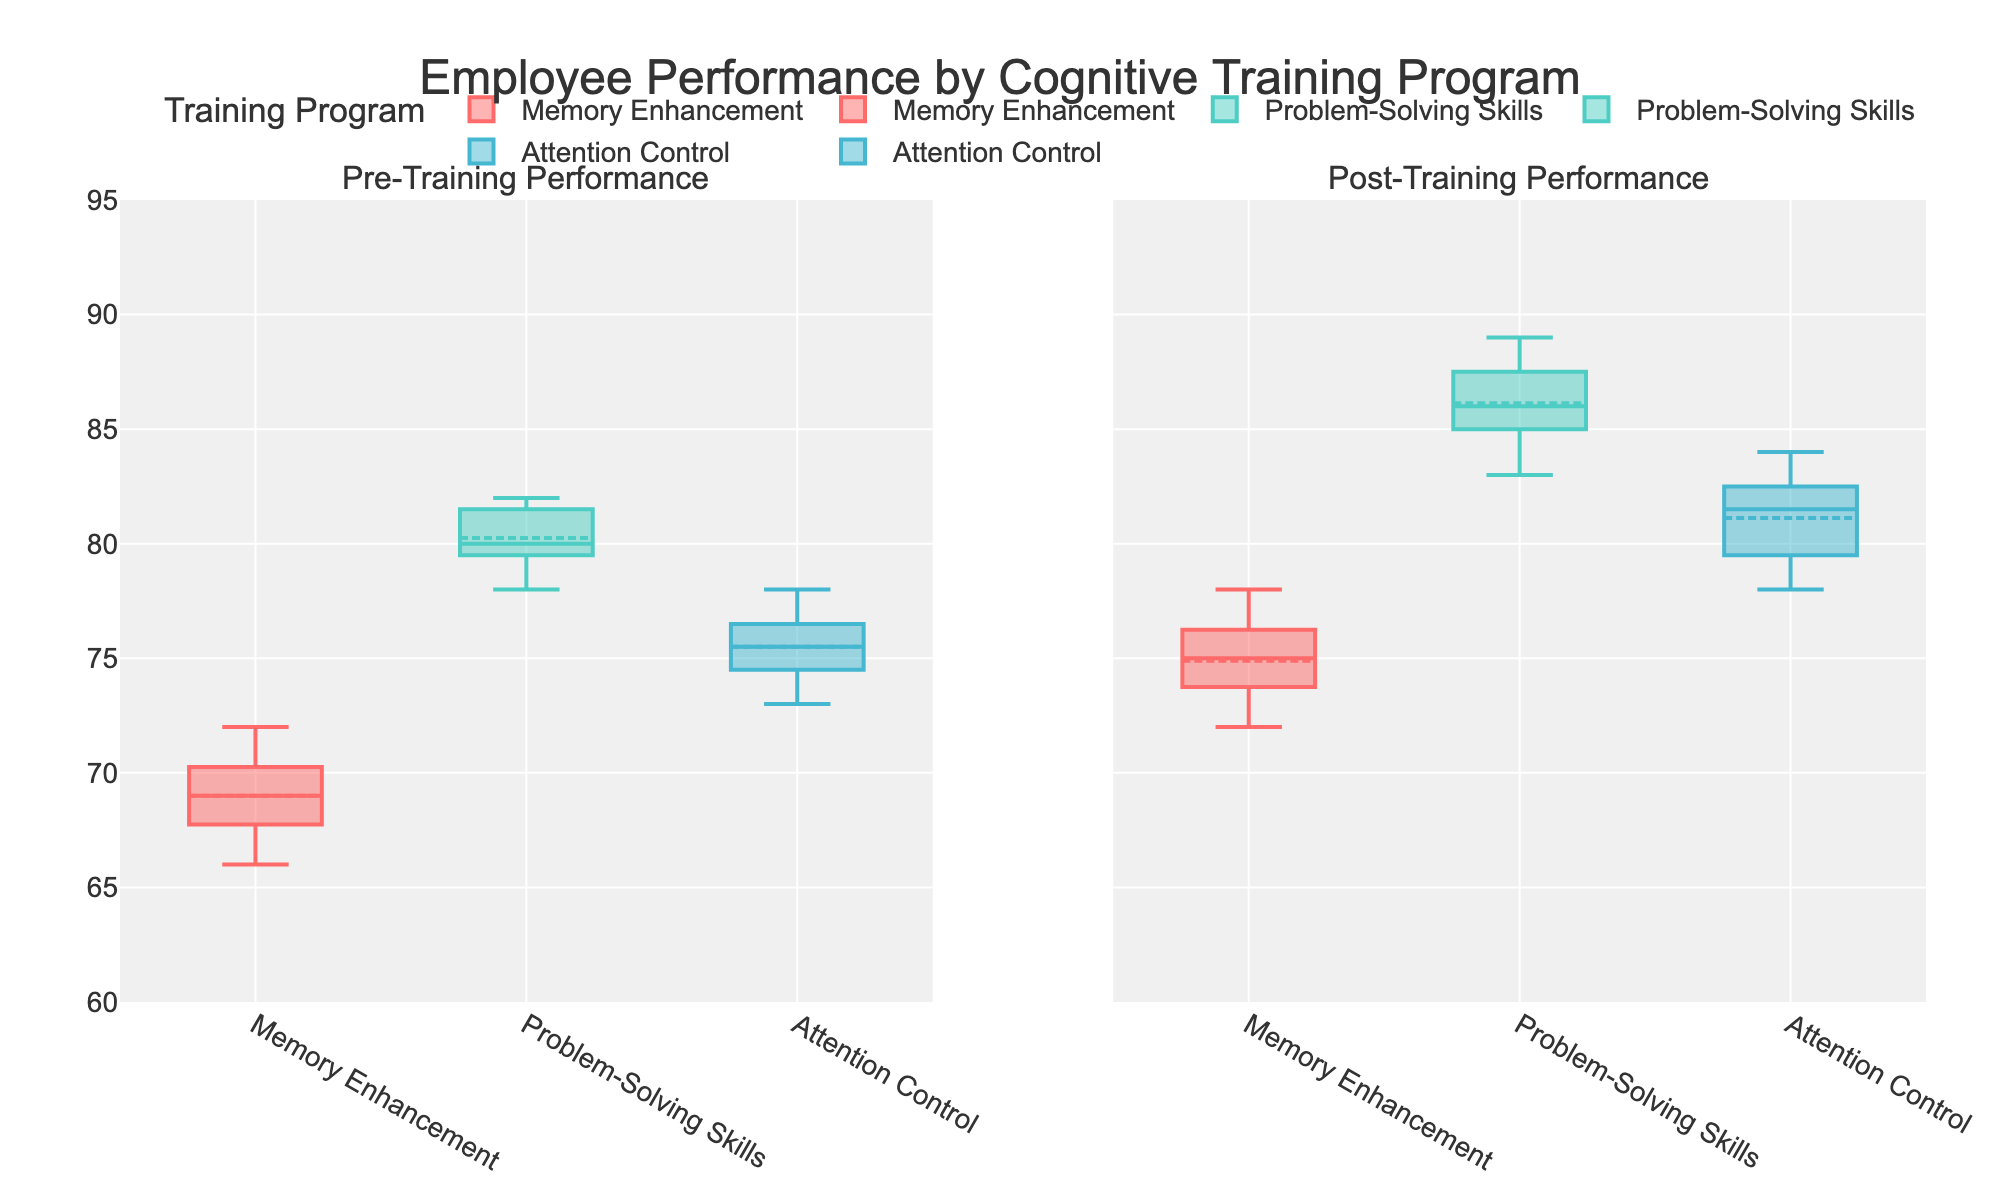what is the title of the plot? The title of the plot is displayed at the top in a larger font size and reads "Employee Performance by Cognitive Training Program".
Answer: Employee Performance by Cognitive Training Program what are the subplot titles? The subplot titles describe the vertical axis of each subplot. The left subplot is titled "Pre-Training Performance" and the right subplot is titled "Post-Training Performance".
Answer: Pre-Training Performance and Post-Training Performance which cognitive training program has the highest median post-training performance score? To determine the highest median post-training performance score, compare the median lines in the boxes of the right subplot. The highest median line belongs to the "Problem-Solving Skills" program.
Answer: Problem-Solving Skills what color represents the "Memory Enhancement" training program? The color representing the "Memory Enhancement" training program can be inferred from the legend. In this case, it is represented by the color red.
Answer: Red what is the range of the y-axis in the plots? The y-axis range can be found by looking at the y-axis numbers displayed on the left and right subplots. The range is from 60 to 95.
Answer: 60 to 95 how do the performance scores change from pre-training to post-training for the "Attention Control" program? Compare the boxes for the "Attention Control" program in both subplots. The median line shifts higher in the post-training box compared to the pre-training box, indicating an increase in performance scores.
Answer: Increase in performance scores which training program showed the greatest improvement in median performance score? To find which training program shows the greatest improvement, compare the median lines' vertical shifts from the pre-training to post-training plots for each program. "Problem-Solving Skills" shows the greatest improvement.
Answer: Problem-Solving Skills what is the interquartile range (IQR) for "Memory Enhancement" pre-training scores? The IQR is the range between the first quartile (Q1) and the third quartile (Q3). For "Memory Enhancement" pre-training scores, find the bottom and top of the box in the left subplot. The IQR is 70 - 66 = 4.
Answer: 4 which program has the smallest range in the pre-training performance scores? The range of scores is the distance between the smallest and largest dots extending vertically from the box. By comparing these ranges in the left subplot, "Problem-Solving Skills" has the smallest range.
Answer: Problem-Solving Skills how many training programs are compared in this analysis? The number of distinct training programs compared can be inferred from the legend and the number of boxes per subplot. Here, there are three programs: "Memory Enhancement", "Problem-Solving Skills", and "Attention Control".
Answer: Three 